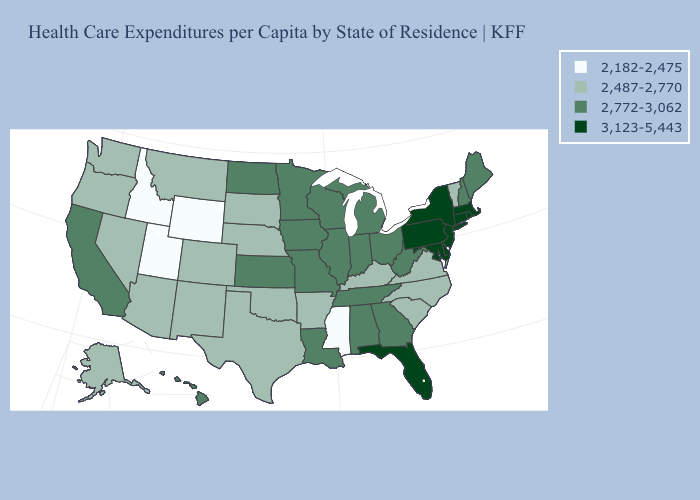Is the legend a continuous bar?
Keep it brief. No. Which states have the lowest value in the USA?
Give a very brief answer. Idaho, Mississippi, Utah, Wyoming. Which states hav the highest value in the Northeast?
Short answer required. Connecticut, Massachusetts, New Jersey, New York, Pennsylvania, Rhode Island. Does the map have missing data?
Keep it brief. No. Among the states that border Colorado , which have the lowest value?
Write a very short answer. Utah, Wyoming. Does the map have missing data?
Concise answer only. No. Among the states that border Indiana , which have the highest value?
Give a very brief answer. Illinois, Michigan, Ohio. Name the states that have a value in the range 2,182-2,475?
Write a very short answer. Idaho, Mississippi, Utah, Wyoming. Name the states that have a value in the range 2,182-2,475?
Quick response, please. Idaho, Mississippi, Utah, Wyoming. Does Georgia have the same value as California?
Be succinct. Yes. What is the lowest value in states that border Tennessee?
Quick response, please. 2,182-2,475. Name the states that have a value in the range 2,772-3,062?
Concise answer only. Alabama, California, Georgia, Hawaii, Illinois, Indiana, Iowa, Kansas, Louisiana, Maine, Michigan, Minnesota, Missouri, New Hampshire, North Dakota, Ohio, Tennessee, West Virginia, Wisconsin. Name the states that have a value in the range 2,182-2,475?
Answer briefly. Idaho, Mississippi, Utah, Wyoming. What is the highest value in states that border Delaware?
Concise answer only. 3,123-5,443. What is the lowest value in the West?
Write a very short answer. 2,182-2,475. 